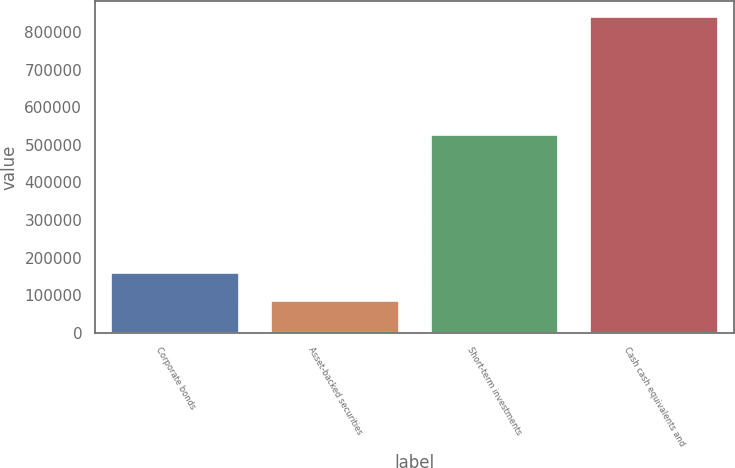Convert chart. <chart><loc_0><loc_0><loc_500><loc_500><bar_chart><fcel>Corporate bonds<fcel>Asset-backed securities<fcel>Short-term investments<fcel>Cash cash equivalents and<nl><fcel>159311<fcel>83044<fcel>527256<fcel>840864<nl></chart> 